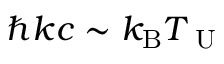Convert formula to latex. <formula><loc_0><loc_0><loc_500><loc_500>\hbar { k } c \sim k _ { B } T _ { U }</formula> 